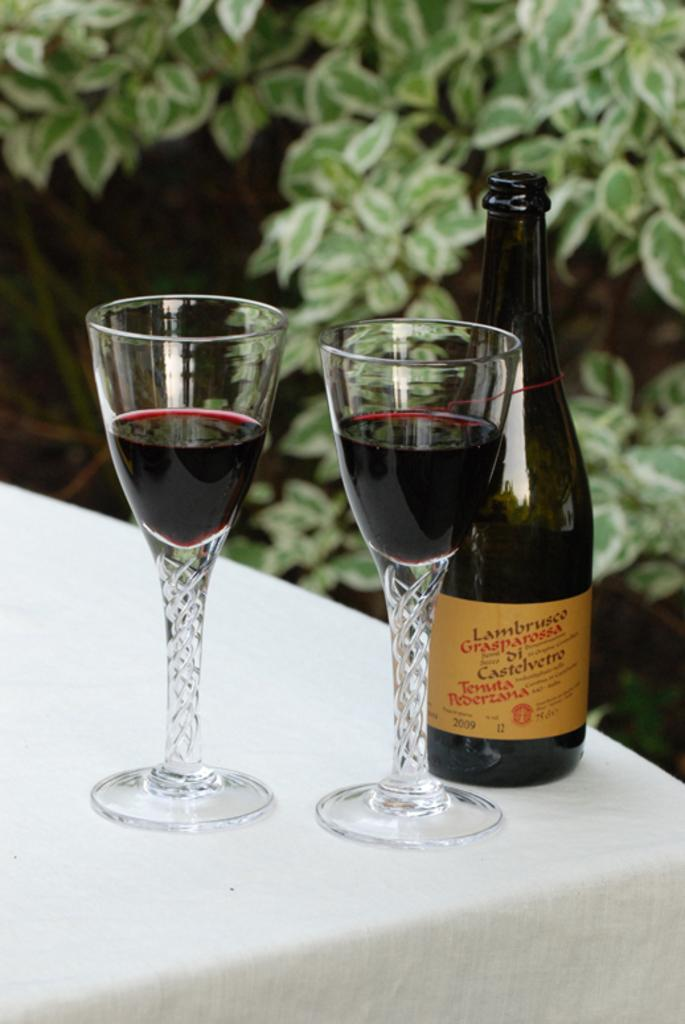What is the main object in the image? There is a table in the image. What is on the table? The table contains glasses and a bottle. What can be seen in the background of the image? There are leaves visible in the background of the image. Is there a power net visible in the image? There is no power net present in the image. Can you see a rifle on the table in the image? There is no rifle present on the table in the image. 